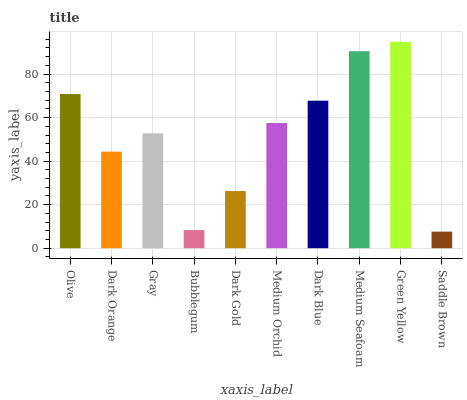Is Saddle Brown the minimum?
Answer yes or no. Yes. Is Green Yellow the maximum?
Answer yes or no. Yes. Is Dark Orange the minimum?
Answer yes or no. No. Is Dark Orange the maximum?
Answer yes or no. No. Is Olive greater than Dark Orange?
Answer yes or no. Yes. Is Dark Orange less than Olive?
Answer yes or no. Yes. Is Dark Orange greater than Olive?
Answer yes or no. No. Is Olive less than Dark Orange?
Answer yes or no. No. Is Medium Orchid the high median?
Answer yes or no. Yes. Is Gray the low median?
Answer yes or no. Yes. Is Dark Blue the high median?
Answer yes or no. No. Is Dark Orange the low median?
Answer yes or no. No. 